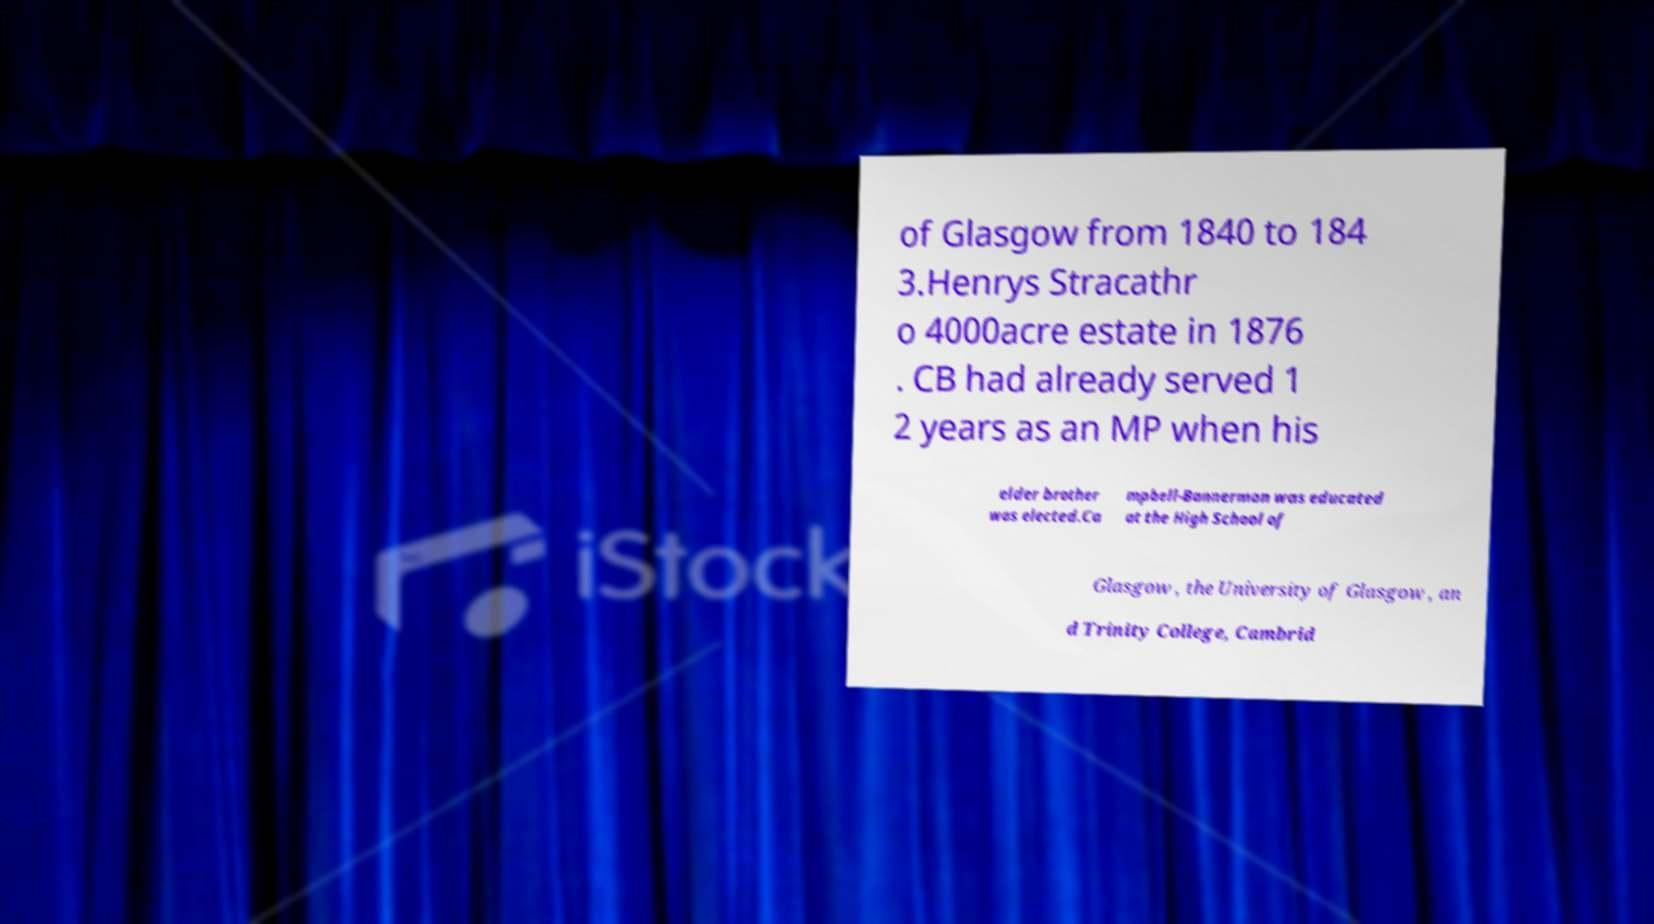Please identify and transcribe the text found in this image. of Glasgow from 1840 to 184 3.Henrys Stracathr o 4000acre estate in 1876 . CB had already served 1 2 years as an MP when his elder brother was elected.Ca mpbell-Bannerman was educated at the High School of Glasgow , the University of Glasgow , an d Trinity College, Cambrid 